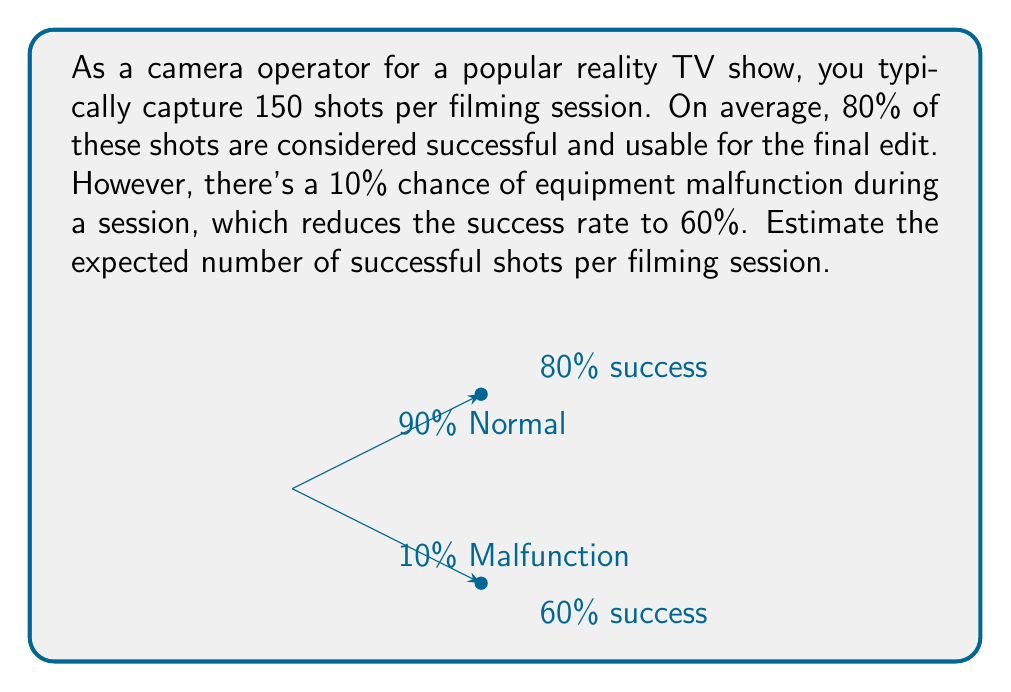Give your solution to this math problem. Let's approach this step-by-step using the concept of expected value:

1) First, let's define our scenarios:
   - Normal operation (90% chance): 80% success rate
   - Equipment malfunction (10% chance): 60% success rate

2) For each scenario, we calculate the number of successful shots:
   - Normal: $150 \times 0.80 = 120$ successful shots
   - Malfunction: $150 \times 0.60 = 90$ successful shots

3) Now, we calculate the expected value using the probability of each scenario:

   $$E(\text{successful shots}) = (0.90 \times 120) + (0.10 \times 90)$$

4) Let's solve this equation:
   $$E(\text{successful shots}) = 108 + 9 = 117$$

Therefore, the expected number of successful shots per filming session is 117.

Note: This calculation assumes that the equipment malfunction, if it occurs, affects the entire session. If the malfunction only affects a portion of the session, the calculation would need to be adjusted accordingly.
Answer: 117 shots 